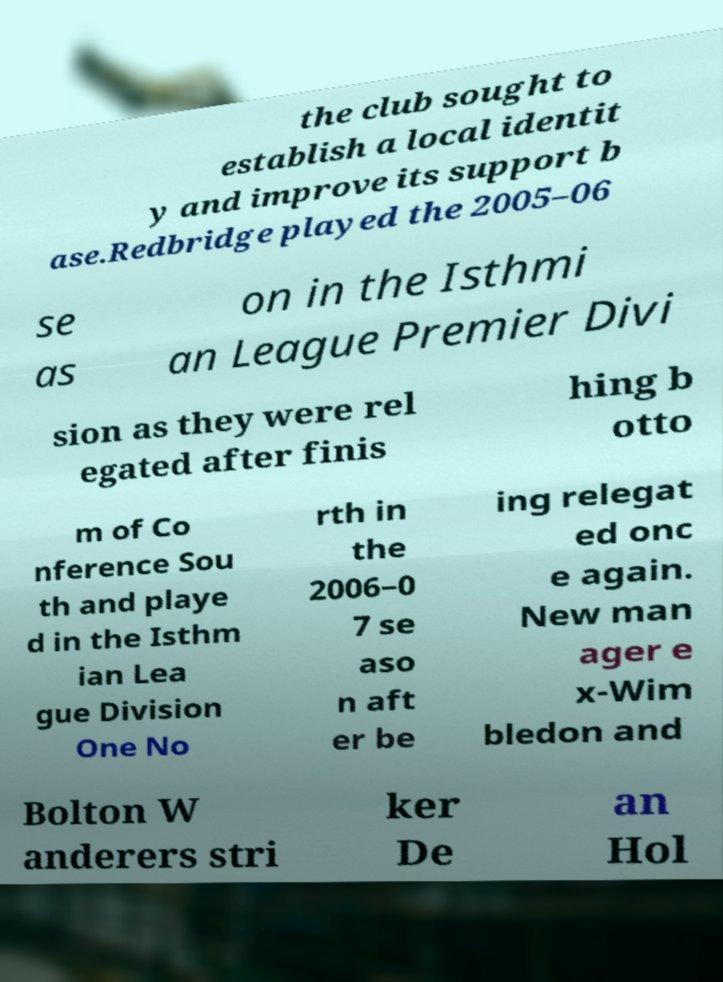Please identify and transcribe the text found in this image. the club sought to establish a local identit y and improve its support b ase.Redbridge played the 2005–06 se as on in the Isthmi an League Premier Divi sion as they were rel egated after finis hing b otto m of Co nference Sou th and playe d in the Isthm ian Lea gue Division One No rth in the 2006–0 7 se aso n aft er be ing relegat ed onc e again. New man ager e x-Wim bledon and Bolton W anderers stri ker De an Hol 